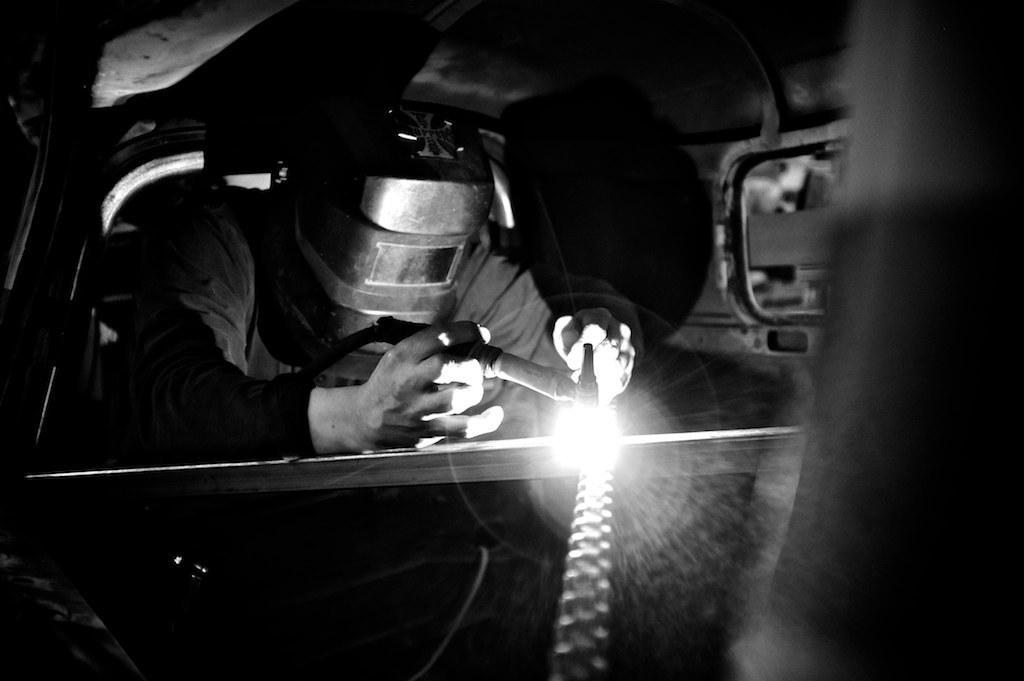What is the color scheme of the image? The image is in black and white. Who or what is the main subject in the image? There is a person in the center of the image. What is the person wearing? The person is wearing a helmet. What objects does the person have in their hands? The person has a torch in one hand and a pipe in the other hand. What might the person be doing in the image? The person appears to be working on something. What type of playground equipment can be seen in the image? There is no playground equipment present in the image. How does the person's work in the image contribute to acoustics? The image does not provide any information about acoustics or the person's work affecting it. 